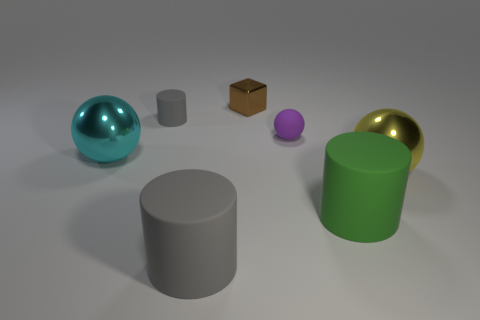Add 2 yellow metallic spheres. How many objects exist? 9 Subtract all cylinders. How many objects are left? 4 Subtract 0 green cubes. How many objects are left? 7 Subtract all gray metal blocks. Subtract all small shiny cubes. How many objects are left? 6 Add 7 big cyan balls. How many big cyan balls are left? 8 Add 4 small cyan metal spheres. How many small cyan metal spheres exist? 4 